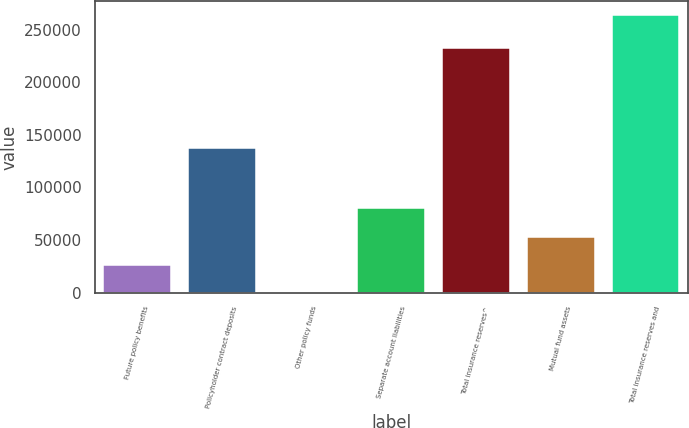<chart> <loc_0><loc_0><loc_500><loc_500><bar_chart><fcel>Future policy benefits<fcel>Policyholder contract deposits<fcel>Other policy funds<fcel>Separate account liabilities<fcel>Total insurance reserves^<fcel>Mutual fund assets<fcel>Total insurance reserves and<nl><fcel>26662.7<fcel>137718<fcel>295<fcel>79960<fcel>232712<fcel>53030.4<fcel>263972<nl></chart> 